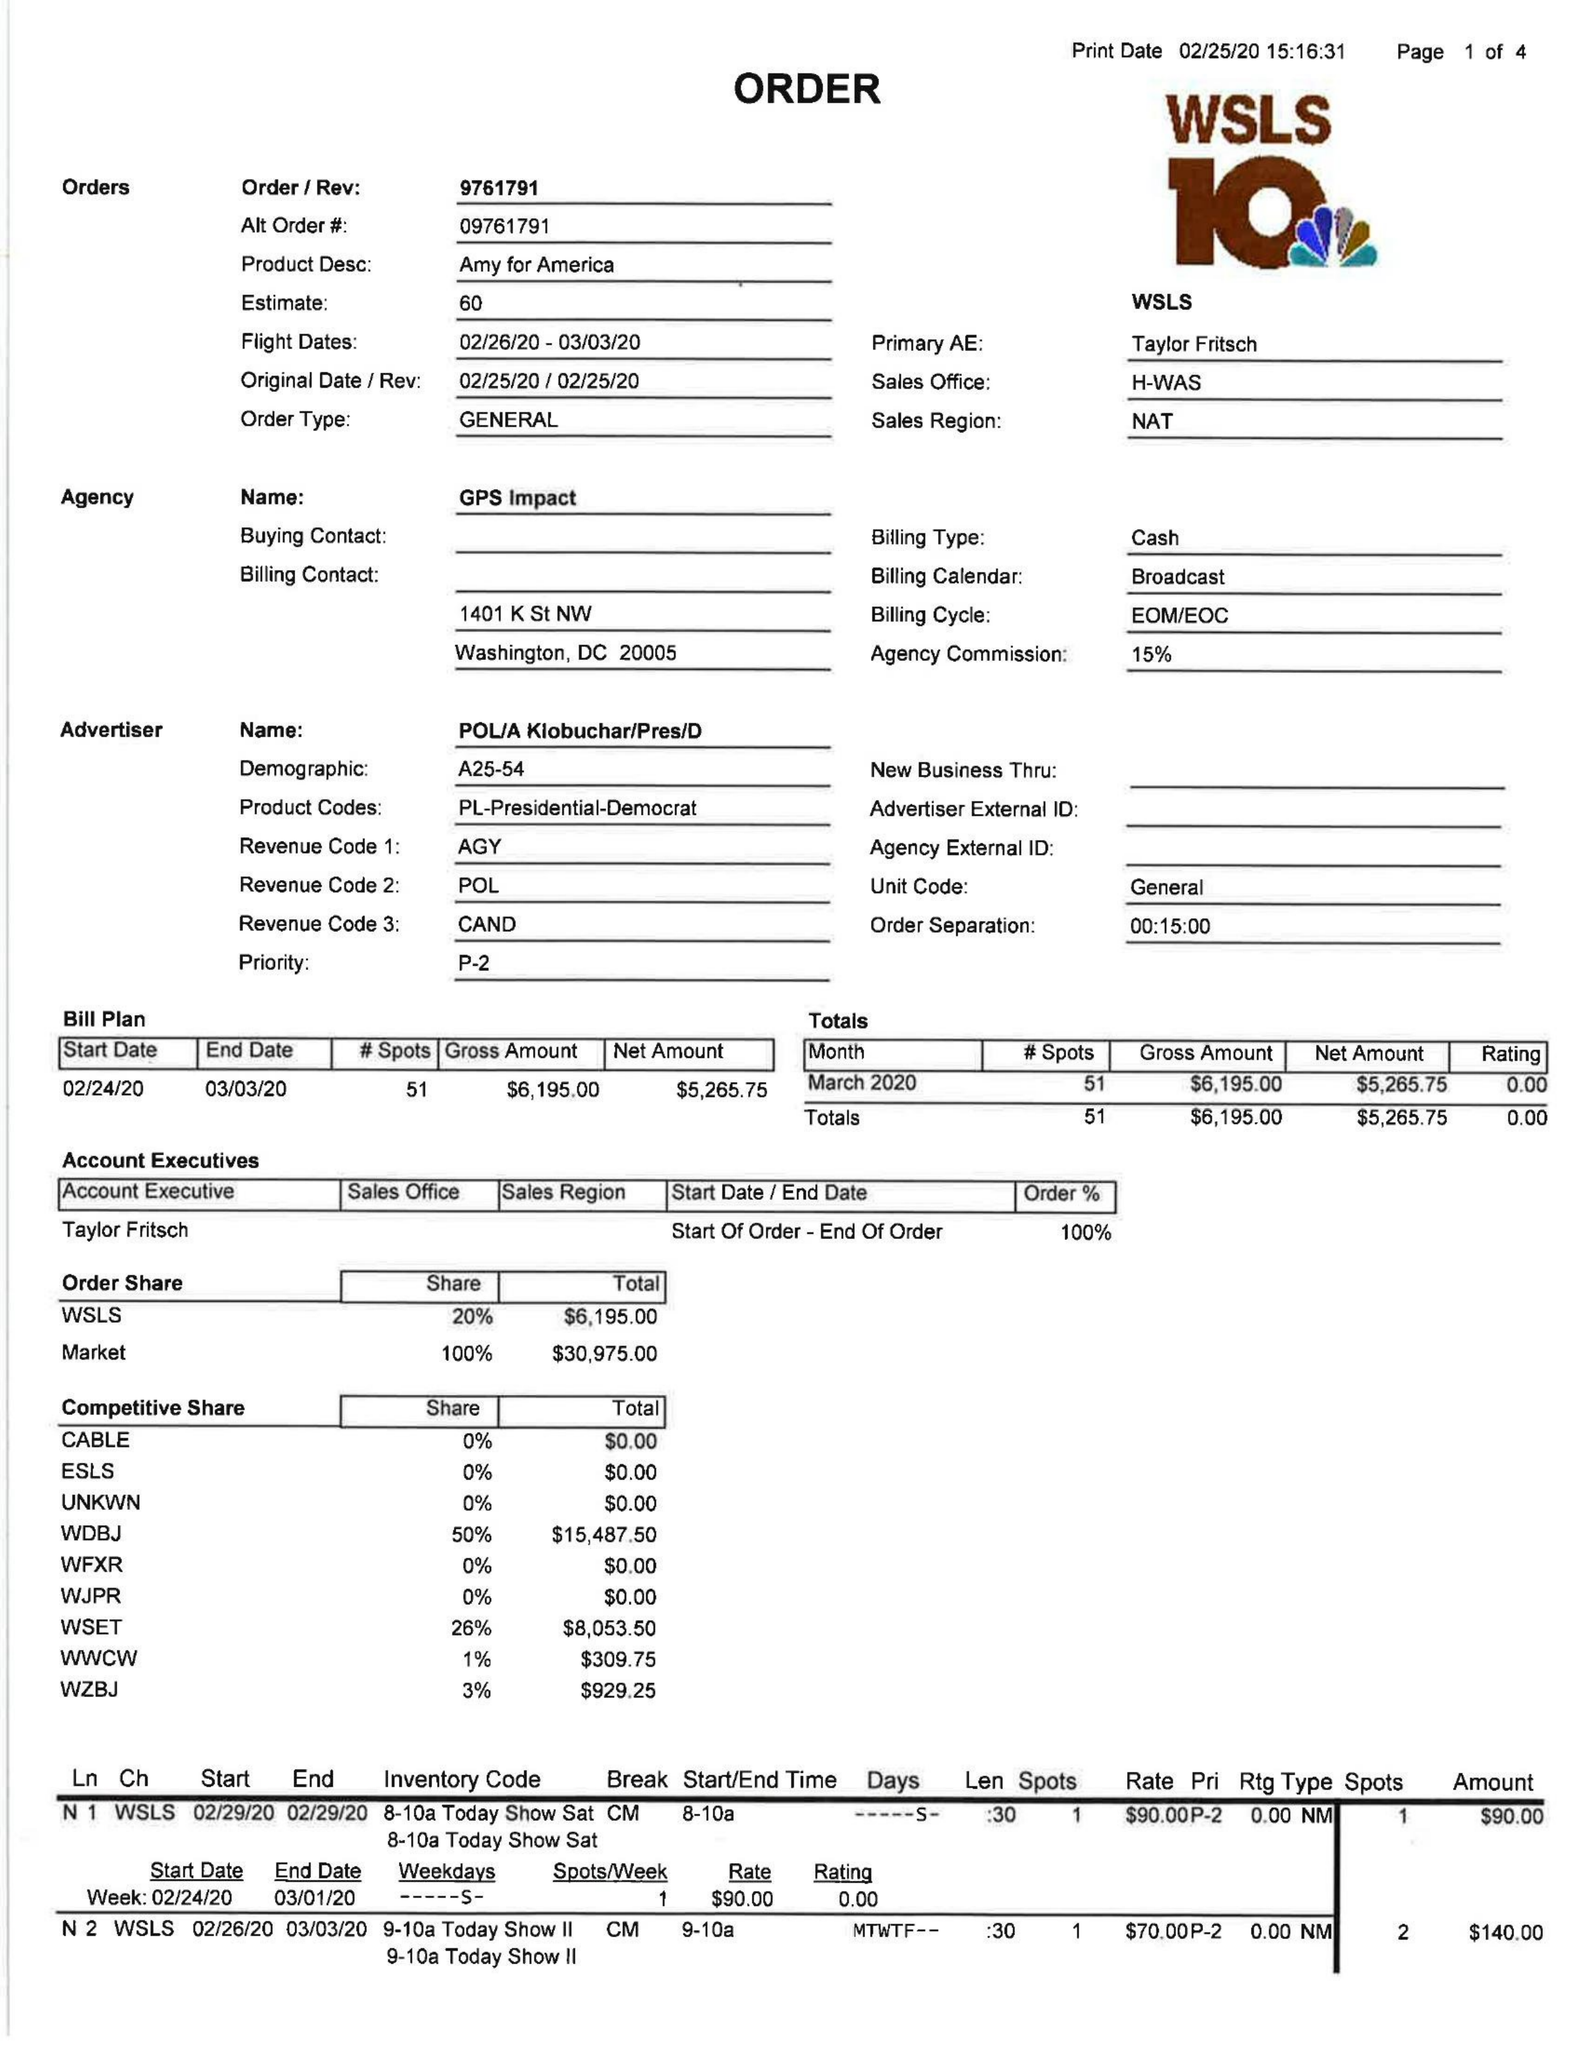What is the value for the advertiser?
Answer the question using a single word or phrase. AMY FOR AMERICA 